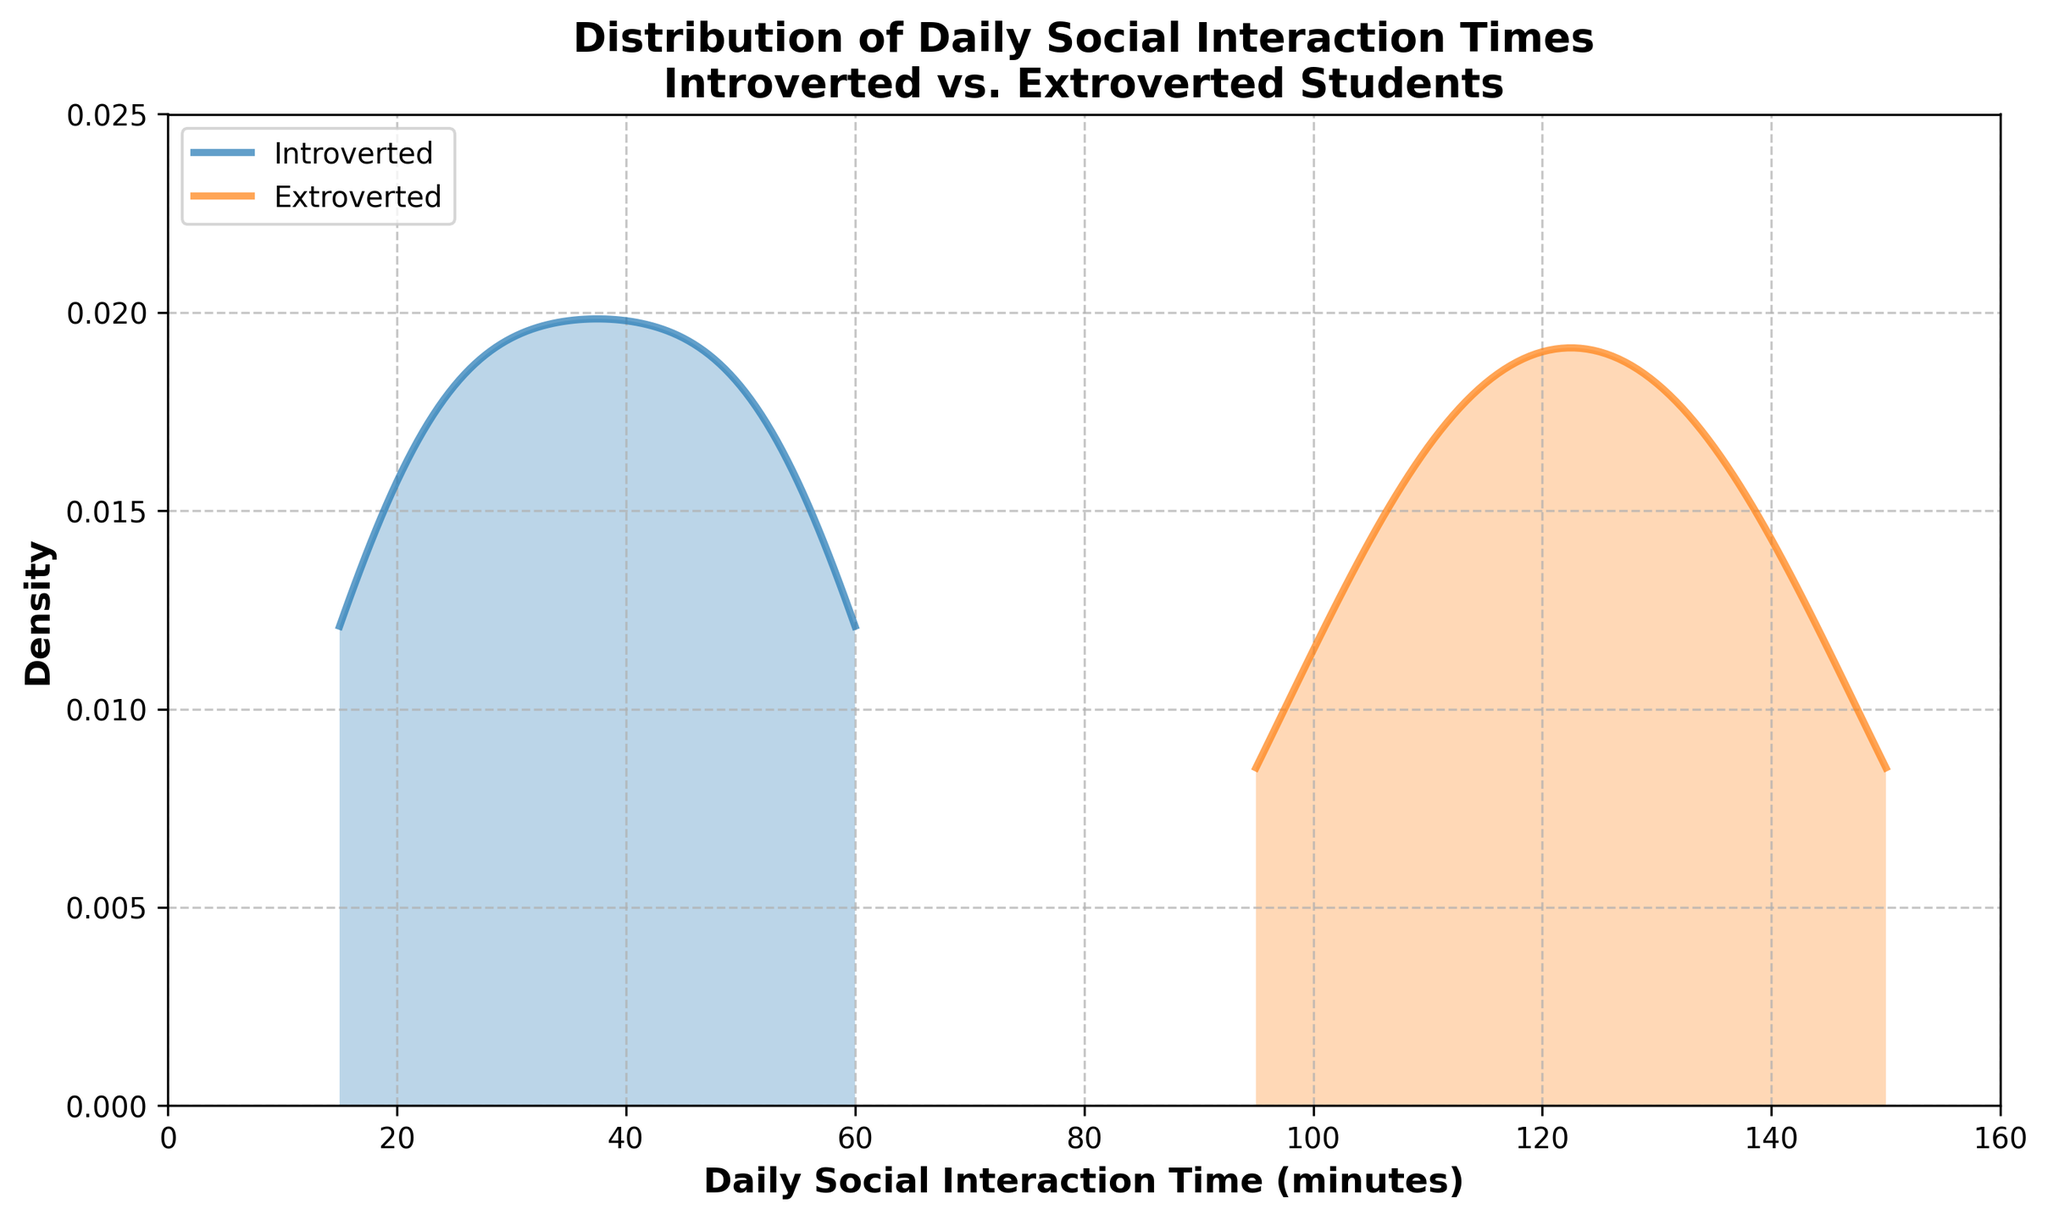What is the title of the plot? The title of the plot is the text at the top of the figure that summarizes its main content. In this case, the title reads "Distribution of Daily Social Interaction Times Introverted vs. Extroverted Students."
Answer: Distribution of Daily Social Interaction Times Introverted vs. Extroverted Students Which group, introverted or extroverted, has the wider range of daily social interaction times? The range can be estimated by looking at the spread of the density curves for each group. The extroverted students' curve spans from around 95 to 150 minutes, while the introverted students' curve spans from around 15 to 60 minutes. Hence, the extroverted group has the wider range.
Answer: Extroverted Between what values of daily social interaction time is the peak density for introverted students? The peak density can be observed at the highest point of the curve for introverted students. The peak appears between approximately 20 and 40 minutes.
Answer: 20-40 minutes Do extroverted students generally spend more time on daily social interactions than introverted students? By comparing the ranges and peaks of both curves, we can see that extroverted students' interaction times are generally higher, spanning from about 95 to 150 minutes, whereas introverted students' interaction times are lower, spanning from about 15 to 60 minutes.
Answer: Yes At what interaction time does the density curve for extroverted students start to decline rapidly? The density curve for extroverted students starts to decline rapidly after reaching its peak, which is around 125 to 135 minutes.
Answer: Around 125-135 minutes Which group shows a higher density of social interaction time around 50 minutes? By comparing the density values visually around the 50-minute mark on the x-axis, the introverted group shows a higher density since its peak density lies around this area.
Answer: Introverted What can you infer about the daily social interaction times based on the density curves for both student types? Based on the density curves, introverted students generally have lower daily social interaction times mostly clustered between 20 and 40 minutes, while extroverted students usually have higher interaction times clustered between 95 and 135 minutes. This suggests introverted students interact less socially compared to extroverted students.
Answer: Introverted students interact less socially compared to extroverted students 